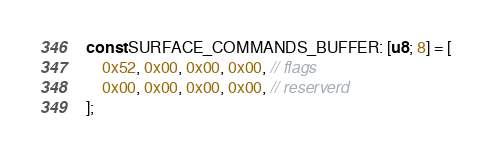<code> <loc_0><loc_0><loc_500><loc_500><_Rust_>
const SURFACE_COMMANDS_BUFFER: [u8; 8] = [
    0x52, 0x00, 0x00, 0x00, // flags
    0x00, 0x00, 0x00, 0x00, // reserverd
];
</code> 